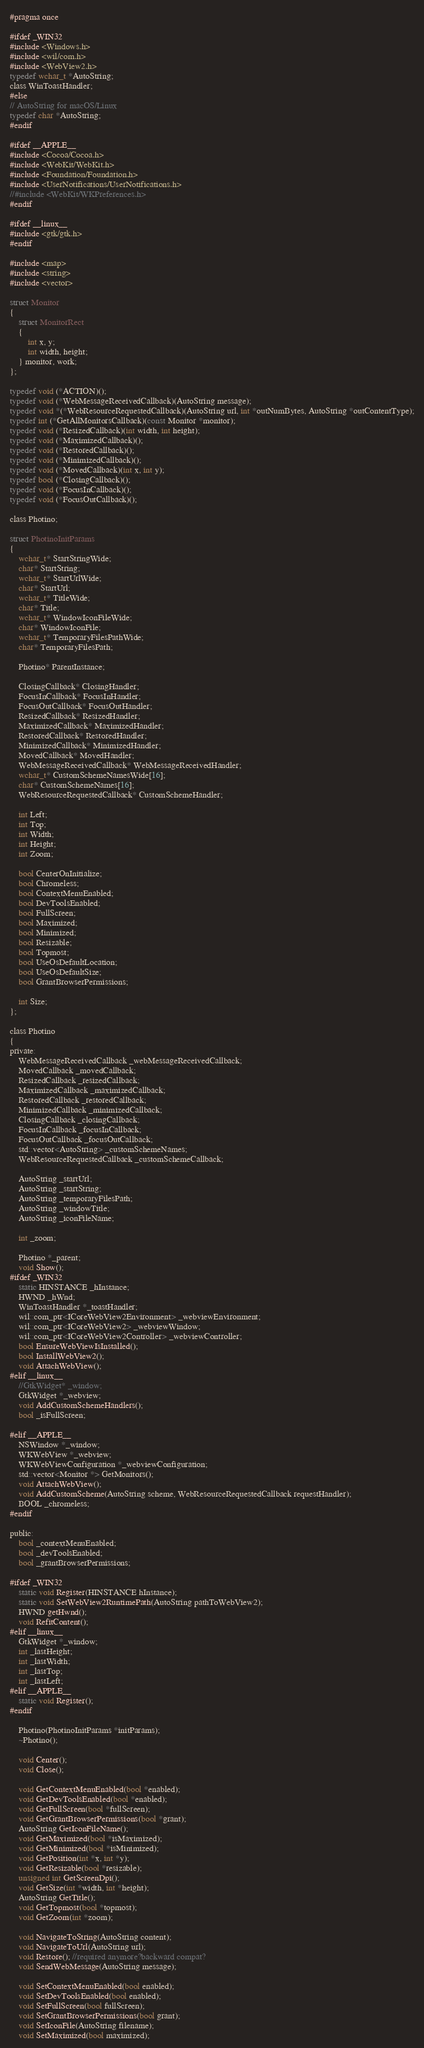Convert code to text. <code><loc_0><loc_0><loc_500><loc_500><_C_>#pragma once

#ifdef _WIN32
#include <Windows.h>
#include <wil/com.h>
#include <WebView2.h>
typedef wchar_t *AutoString;
class WinToastHandler;
#else
// AutoString for macOS/Linux
typedef char *AutoString;
#endif

#ifdef __APPLE__
#include <Cocoa/Cocoa.h>
#include <WebKit/WebKit.h>
#include <Foundation/Foundation.h>
#include <UserNotifications/UserNotifications.h>
//#include <WebKit/WKPreferences.h>
#endif

#ifdef __linux__
#include <gtk/gtk.h>
#endif

#include <map>
#include <string>
#include <vector>

struct Monitor
{
	struct MonitorRect
	{
		int x, y;
		int width, height;
	} monitor, work;
};

typedef void (*ACTION)();
typedef void (*WebMessageReceivedCallback)(AutoString message);
typedef void *(*WebResourceRequestedCallback)(AutoString url, int *outNumBytes, AutoString *outContentType);
typedef int (*GetAllMonitorsCallback)(const Monitor *monitor);
typedef void (*ResizedCallback)(int width, int height);
typedef void (*MaximizedCallback)();
typedef void (*RestoredCallback)();
typedef void (*MinimizedCallback)();
typedef void (*MovedCallback)(int x, int y);
typedef bool (*ClosingCallback)();
typedef void (*FocusInCallback)();
typedef void (*FocusOutCallback)();

class Photino;

struct PhotinoInitParams
{
	wchar_t* StartStringWide;
	char* StartString;
	wchar_t* StartUrlWide;
	char* StartUrl;
	wchar_t* TitleWide;
	char* Title;
	wchar_t* WindowIconFileWide;
	char* WindowIconFile;
	wchar_t* TemporaryFilesPathWide;
	char* TemporaryFilesPath;

	Photino* ParentInstance;

	ClosingCallback* ClosingHandler;
	FocusInCallback* FocusInHandler;
	FocusOutCallback* FocusOutHandler;
	ResizedCallback* ResizedHandler;
	MaximizedCallback* MaximizedHandler;
	RestoredCallback* RestoredHandler;
	MinimizedCallback* MinimizedHandler;
	MovedCallback* MovedHandler;
	WebMessageReceivedCallback* WebMessageReceivedHandler;
	wchar_t* CustomSchemeNamesWide[16];
	char* CustomSchemeNames[16];
	WebResourceRequestedCallback* CustomSchemeHandler;

	int Left;
	int Top;
	int Width;
	int Height;
	int Zoom;

	bool CenterOnInitialize;
	bool Chromeless;
	bool ContextMenuEnabled;
	bool DevToolsEnabled;
	bool FullScreen;
	bool Maximized;
	bool Minimized;
	bool Resizable;
	bool Topmost;
	bool UseOsDefaultLocation;
	bool UseOsDefaultSize;
	bool GrantBrowserPermissions;

	int Size;
};

class Photino
{
private:
	WebMessageReceivedCallback _webMessageReceivedCallback;
	MovedCallback _movedCallback;
	ResizedCallback _resizedCallback;
	MaximizedCallback _maximizedCallback;
	RestoredCallback _restoredCallback;
	MinimizedCallback _minimizedCallback;
	ClosingCallback _closingCallback;
	FocusInCallback _focusInCallback;
	FocusOutCallback _focusOutCallback;
	std::vector<AutoString> _customSchemeNames;
	WebResourceRequestedCallback _customSchemeCallback;

	AutoString _startUrl;
	AutoString _startString;
	AutoString _temporaryFilesPath;
	AutoString _windowTitle;
	AutoString _iconFileName;

	int _zoom;

	Photino *_parent;
	void Show();
#ifdef _WIN32
	static HINSTANCE _hInstance;
	HWND _hWnd;
	WinToastHandler *_toastHandler;
	wil::com_ptr<ICoreWebView2Environment> _webviewEnvironment;
	wil::com_ptr<ICoreWebView2> _webviewWindow;
	wil::com_ptr<ICoreWebView2Controller> _webviewController;
	bool EnsureWebViewIsInstalled();
	bool InstallWebView2();
	void AttachWebView();
#elif __linux__
	//GtkWidget* _window;
	GtkWidget *_webview;
	void AddCustomSchemeHandlers();
	bool _isFullScreen;

#elif __APPLE__
	NSWindow *_window;
	WKWebView *_webview;
	WKWebViewConfiguration *_webviewConfiguration;
	std::vector<Monitor *> GetMonitors();
	void AttachWebView();
	void AddCustomScheme(AutoString scheme, WebResourceRequestedCallback requestHandler);
	BOOL _chromeless;
#endif

public:
	bool _contextMenuEnabled;
	bool _devToolsEnabled;
	bool _grantBrowserPermissions;

#ifdef _WIN32
	static void Register(HINSTANCE hInstance);
	static void SetWebView2RuntimePath(AutoString pathToWebView2);
	HWND getHwnd();
	void RefitContent();
#elif __linux__
	GtkWidget *_window;
	int _lastHeight;
	int _lastWidth;
	int _lastTop;
	int _lastLeft;
#elif __APPLE__
	static void Register();
#endif

	Photino(PhotinoInitParams *initParams);
	~Photino();

	void Center();
	void Close();

	void GetContextMenuEnabled(bool *enabled);
	void GetDevToolsEnabled(bool *enabled);
	void GetFullScreen(bool *fullScreen);
	void GetGrantBrowserPermissions(bool *grant);
	AutoString GetIconFileName();
	void GetMaximized(bool *isMaximized);
	void GetMinimized(bool *isMinimized);
	void GetPosition(int *x, int *y);
	void GetResizable(bool *resizable);
	unsigned int GetScreenDpi();
	void GetSize(int *width, int *height);
	AutoString GetTitle();
	void GetTopmost(bool *topmost);
	void GetZoom(int *zoom);

	void NavigateToString(AutoString content);
	void NavigateToUrl(AutoString url);
	void Restore(); //required anymore?backward compat?
	void SendWebMessage(AutoString message);

	void SetContextMenuEnabled(bool enabled);
	void SetDevToolsEnabled(bool enabled);
	void SetFullScreen(bool fullScreen);
	void SetGrantBrowserPermissions(bool grant);
	void SetIconFile(AutoString filename);
	void SetMaximized(bool maximized);</code> 